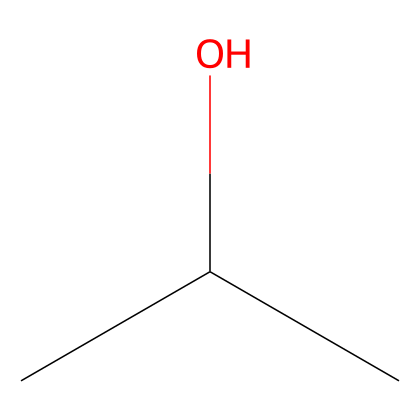How many carbon atoms are in isopropyl alcohol? The SMILES representation "CC(C)O" indicates that there are three carbon atoms (the 'C's) and no additional carbon nodes outside of what's rendered, confirming that isopropyl alcohol has three carbon atoms.
Answer: three What functional group is present in isopropyl alcohol? Based on the SMILES, "O" at the end indicates the presence of a hydroxyl group (-OH), which is characteristic of alcohols. This confirms that isopropyl alcohol has a hydroxyl functional group.
Answer: hydroxyl How many hydrogen atoms are in isopropyl alcohol? The structure "CC(C)O" comprises three carbon atoms and one hydroxyl group. Each carbon typically bonds with enough hydrogen to fulfill the tetravalency (four bonds), leading to a total of eight hydrogen atoms when considering the structure of isopropyl alcohol.
Answer: eight Is isopropyl alcohol a primary, secondary, or tertiary alcohol? The SMILES "CC(C)O" shows that the hydroxyl group is attached to a carbon atom that is itself bonded to two other carbon atoms, hence it is classified as a secondary alcohol.
Answer: secondary What is the boiling point range of isopropyl alcohol? For isopropyl alcohol, commonly known boiling point is between 82 to 83 degrees Celsius, which indicates its volatility as a flammable liquid.
Answer: 82-83 degrees Celsius 